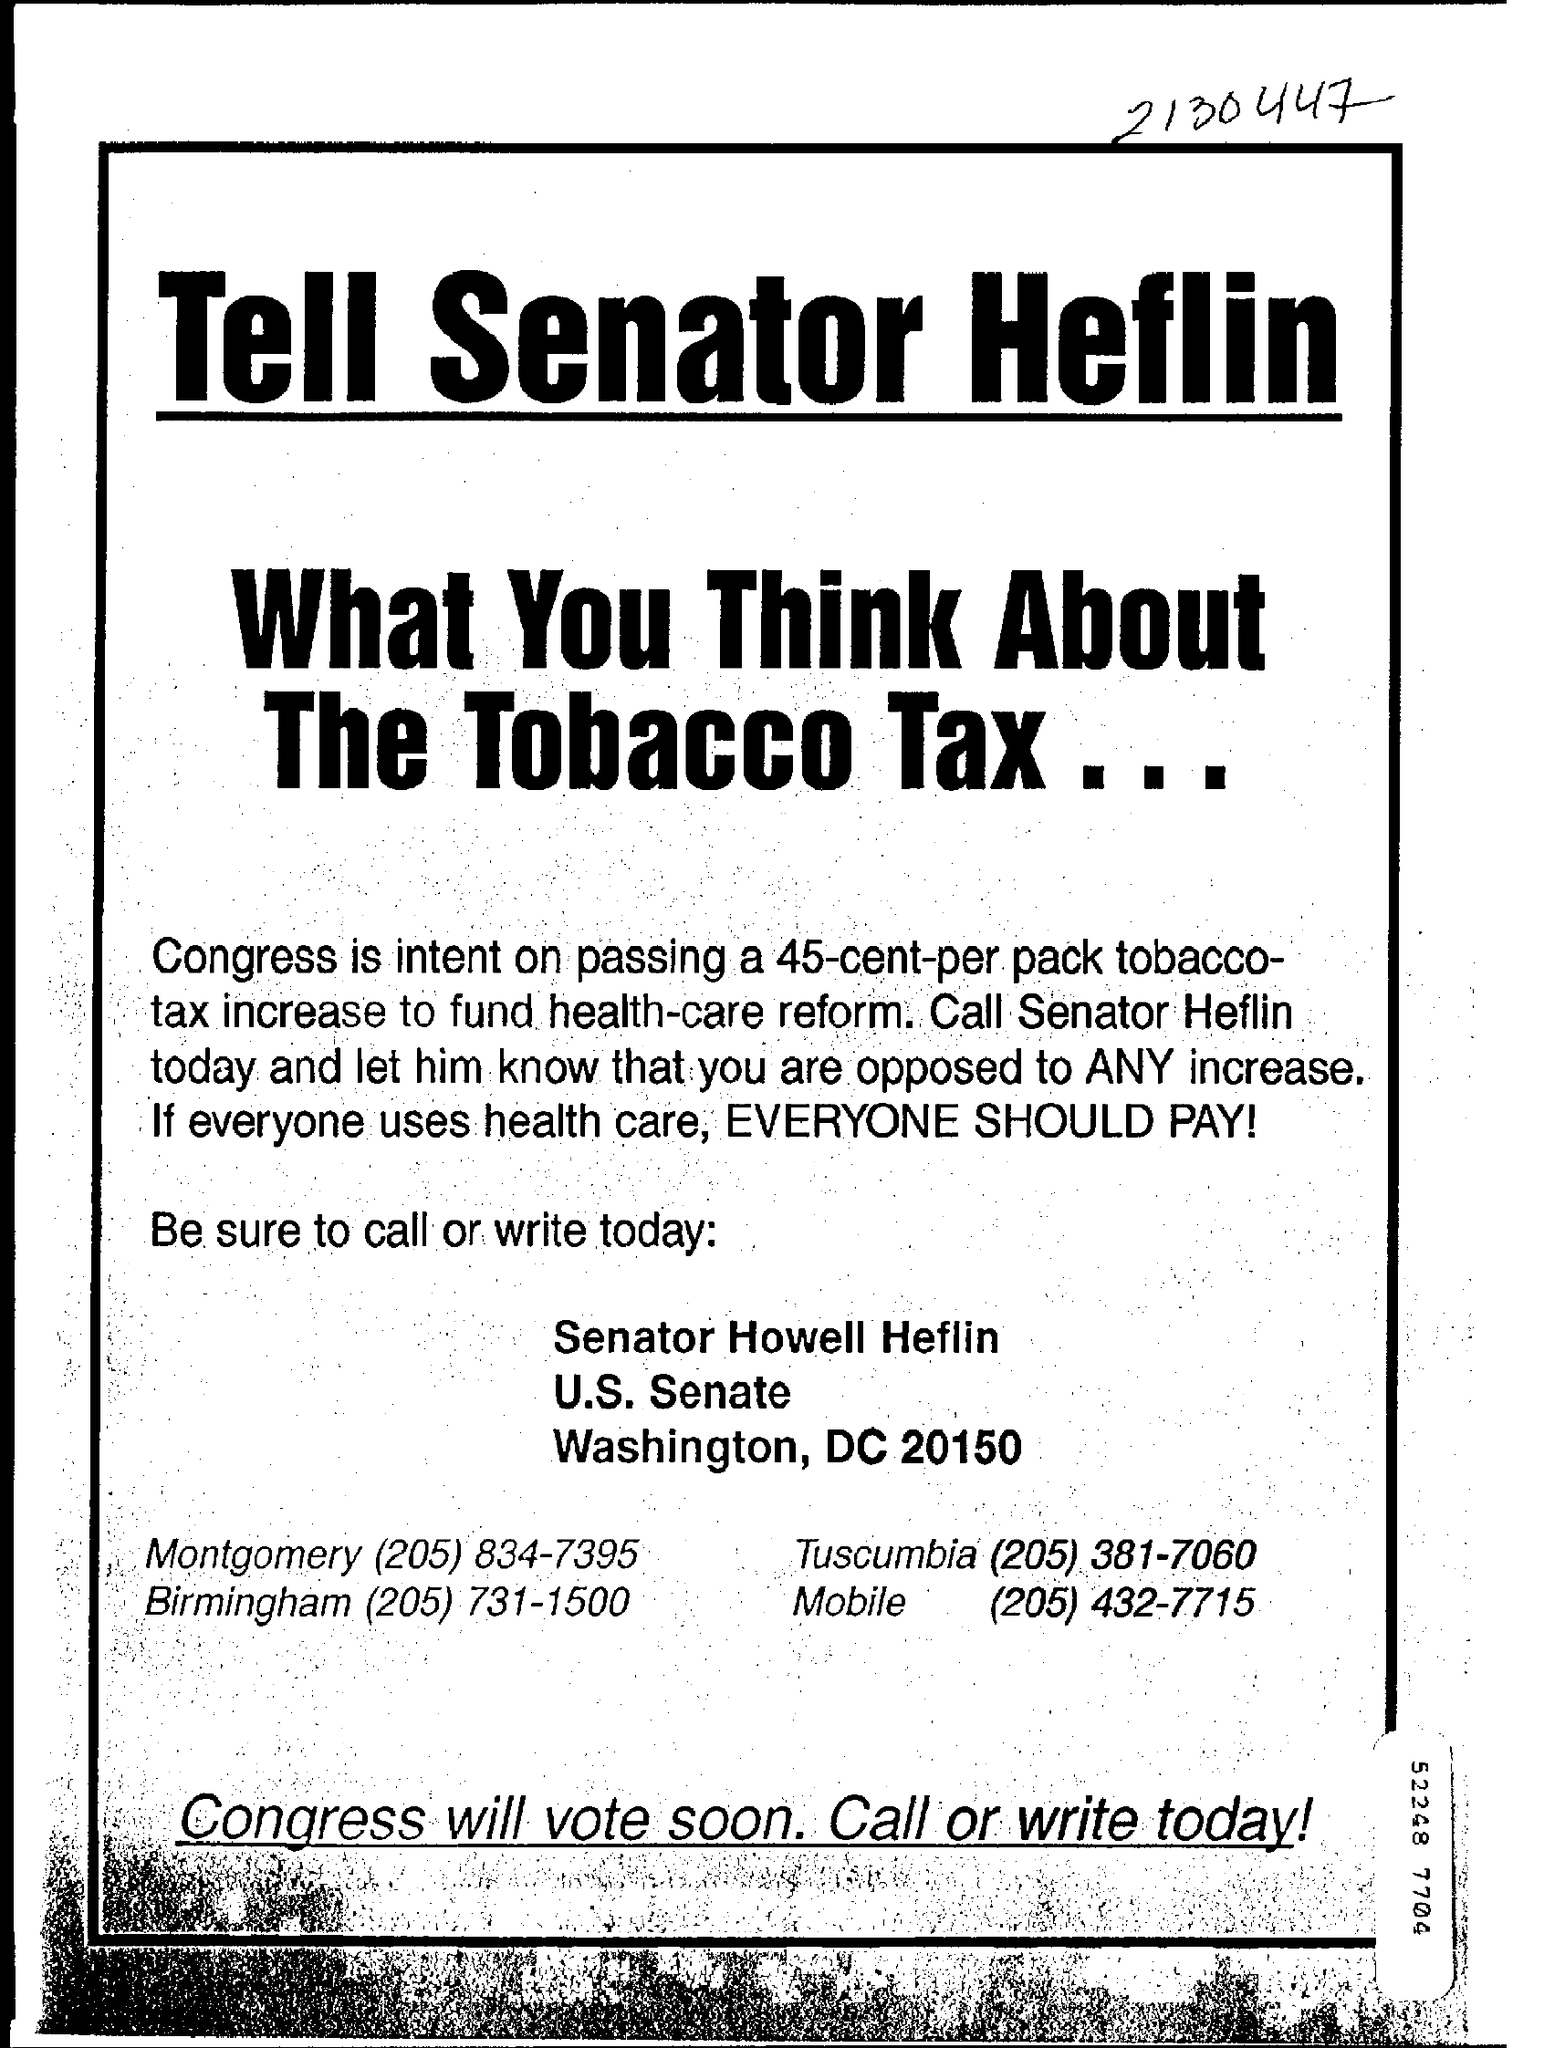How much is the tax increase congress is intent on passing?
Your answer should be compact. 45-cent-per pack tobacoo-tax increase. What is the mobile number mentioned?
Ensure brevity in your answer.  (205) 432-7715. 